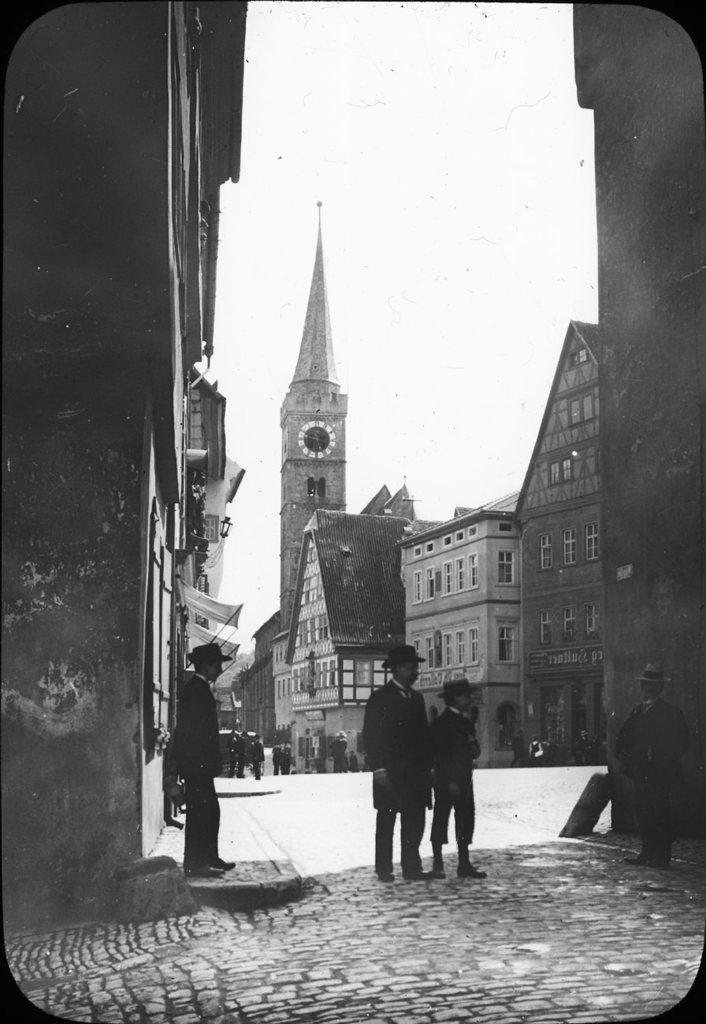In one or two sentences, can you explain what this image depicts? This is a black and white image. Here I can see three people are standing on the ground. In the background, I can see few people are walking on the road. In the background there are many buildings. At the top I can see the sky. 